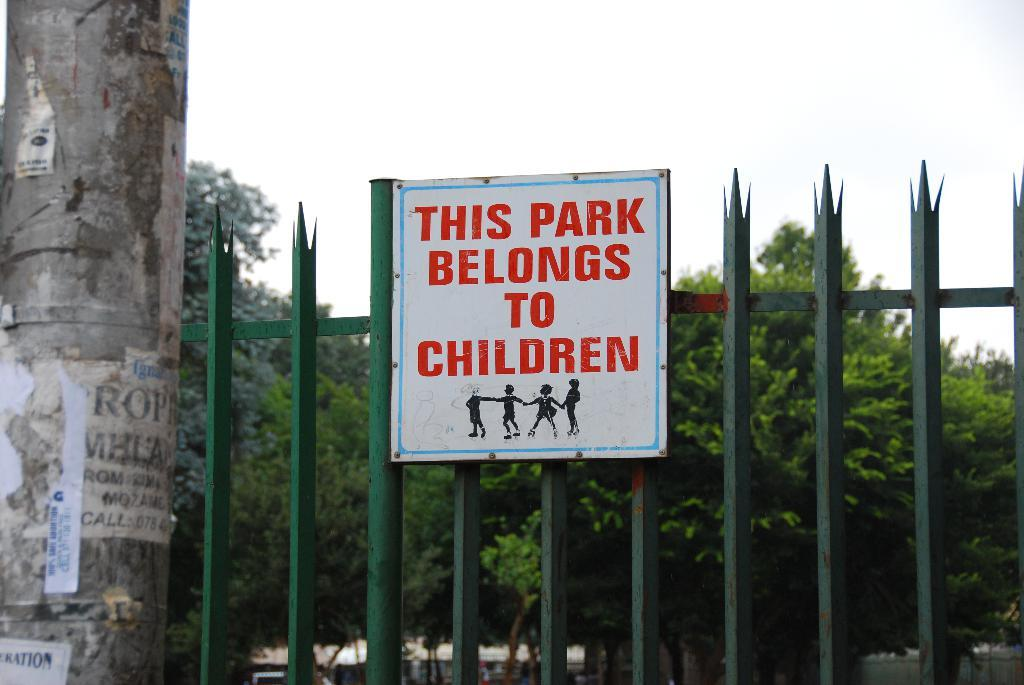What is located in the foreground of the picture? There is a gate, a pole, and a hoarding in the foreground of the picture. Can you describe the objects in the foreground? The gate is a structure that allows access, the pole is a vertical object, and the hoarding is a large sign or advertisement. What can be seen in the background of the picture? There are trees and a building in the background of the picture. What type of chess piece is on top of the building in the image? There is no chess piece visible on top of the building in the image. How does the dust affect the visibility of the trees in the background? There is no mention of dust in the image, so it cannot be determined how it would affect the visibility of the trees. 